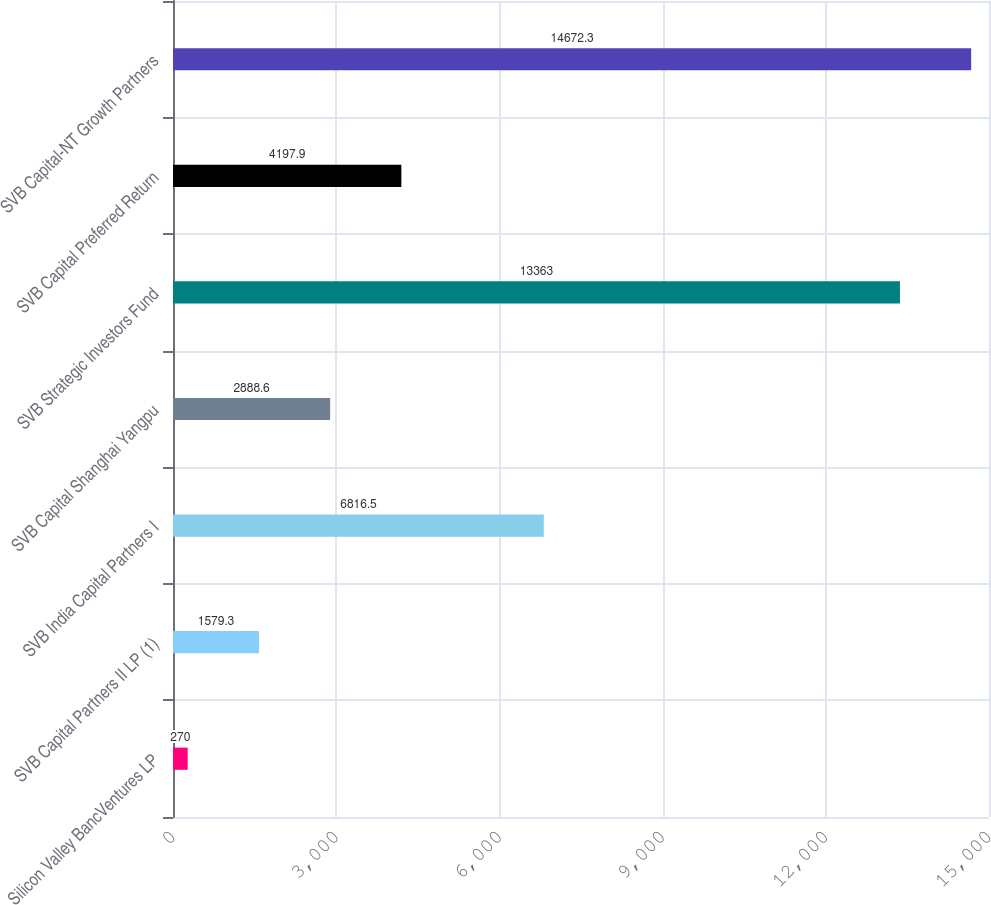Convert chart to OTSL. <chart><loc_0><loc_0><loc_500><loc_500><bar_chart><fcel>Silicon Valley BancVentures LP<fcel>SVB Capital Partners II LP (1)<fcel>SVB India Capital Partners I<fcel>SVB Capital Shanghai Yangpu<fcel>SVB Strategic Investors Fund<fcel>SVB Capital Preferred Return<fcel>SVB Capital-NT Growth Partners<nl><fcel>270<fcel>1579.3<fcel>6816.5<fcel>2888.6<fcel>13363<fcel>4197.9<fcel>14672.3<nl></chart> 